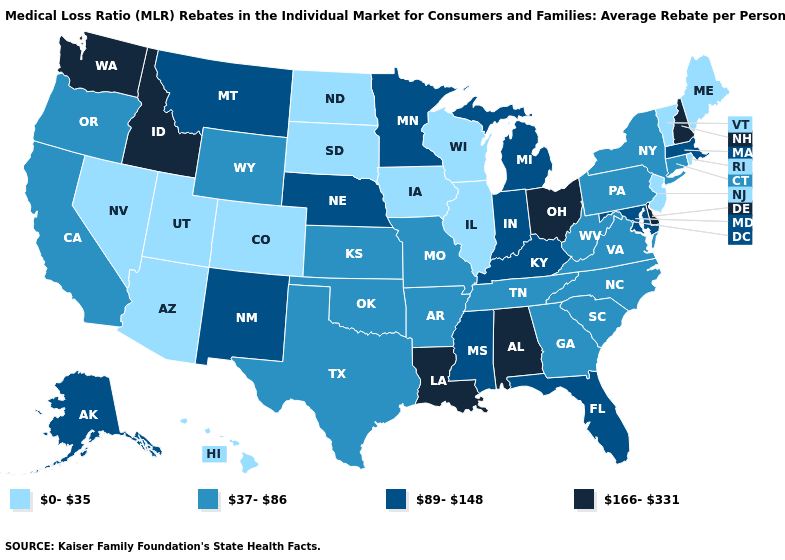Name the states that have a value in the range 37-86?
Answer briefly. Arkansas, California, Connecticut, Georgia, Kansas, Missouri, New York, North Carolina, Oklahoma, Oregon, Pennsylvania, South Carolina, Tennessee, Texas, Virginia, West Virginia, Wyoming. Which states have the lowest value in the USA?
Keep it brief. Arizona, Colorado, Hawaii, Illinois, Iowa, Maine, Nevada, New Jersey, North Dakota, Rhode Island, South Dakota, Utah, Vermont, Wisconsin. What is the highest value in the Northeast ?
Be succinct. 166-331. Does Michigan have the highest value in the USA?
Short answer required. No. Name the states that have a value in the range 37-86?
Short answer required. Arkansas, California, Connecticut, Georgia, Kansas, Missouri, New York, North Carolina, Oklahoma, Oregon, Pennsylvania, South Carolina, Tennessee, Texas, Virginia, West Virginia, Wyoming. Which states hav the highest value in the West?
Answer briefly. Idaho, Washington. Does the map have missing data?
Give a very brief answer. No. Does New York have the lowest value in the USA?
Answer briefly. No. How many symbols are there in the legend?
Short answer required. 4. Does Alaska have a lower value than Mississippi?
Be succinct. No. Name the states that have a value in the range 0-35?
Be succinct. Arizona, Colorado, Hawaii, Illinois, Iowa, Maine, Nevada, New Jersey, North Dakota, Rhode Island, South Dakota, Utah, Vermont, Wisconsin. How many symbols are there in the legend?
Give a very brief answer. 4. Does Idaho have the highest value in the West?
Give a very brief answer. Yes. Does Montana have the highest value in the West?
Write a very short answer. No. What is the value of Rhode Island?
Quick response, please. 0-35. 